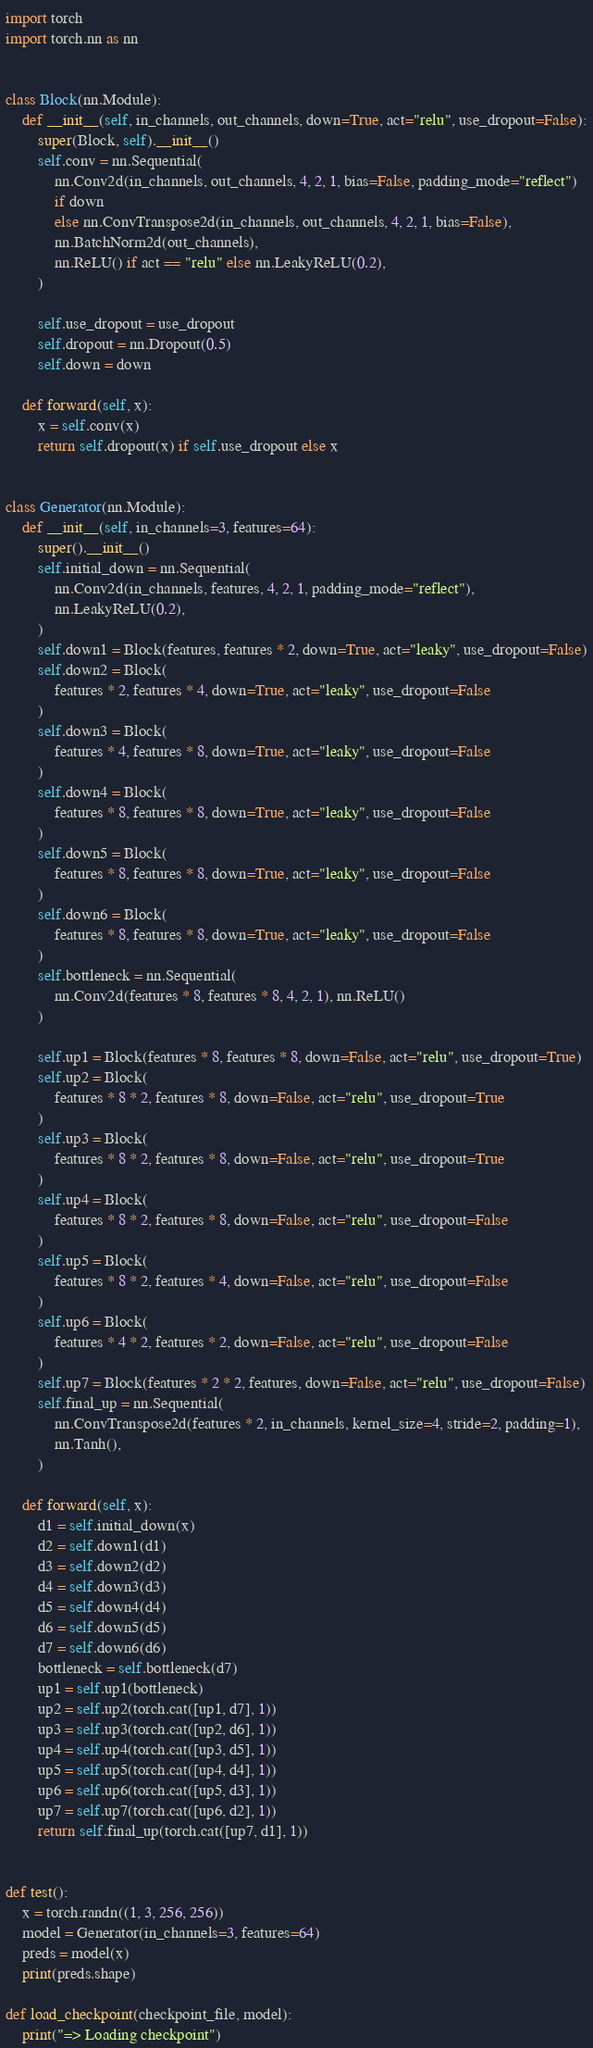Convert code to text. <code><loc_0><loc_0><loc_500><loc_500><_Python_>import torch
import torch.nn as nn


class Block(nn.Module):
    def __init__(self, in_channels, out_channels, down=True, act="relu", use_dropout=False):
        super(Block, self).__init__()
        self.conv = nn.Sequential(
            nn.Conv2d(in_channels, out_channels, 4, 2, 1, bias=False, padding_mode="reflect")
            if down
            else nn.ConvTranspose2d(in_channels, out_channels, 4, 2, 1, bias=False),
            nn.BatchNorm2d(out_channels),
            nn.ReLU() if act == "relu" else nn.LeakyReLU(0.2),
        )

        self.use_dropout = use_dropout
        self.dropout = nn.Dropout(0.5)
        self.down = down

    def forward(self, x):
        x = self.conv(x)
        return self.dropout(x) if self.use_dropout else x


class Generator(nn.Module):
    def __init__(self, in_channels=3, features=64):
        super().__init__()
        self.initial_down = nn.Sequential(
            nn.Conv2d(in_channels, features, 4, 2, 1, padding_mode="reflect"),
            nn.LeakyReLU(0.2),
        )
        self.down1 = Block(features, features * 2, down=True, act="leaky", use_dropout=False)
        self.down2 = Block(
            features * 2, features * 4, down=True, act="leaky", use_dropout=False
        )
        self.down3 = Block(
            features * 4, features * 8, down=True, act="leaky", use_dropout=False
        )
        self.down4 = Block(
            features * 8, features * 8, down=True, act="leaky", use_dropout=False
        )
        self.down5 = Block(
            features * 8, features * 8, down=True, act="leaky", use_dropout=False
        )
        self.down6 = Block(
            features * 8, features * 8, down=True, act="leaky", use_dropout=False
        )
        self.bottleneck = nn.Sequential(
            nn.Conv2d(features * 8, features * 8, 4, 2, 1), nn.ReLU()
        )

        self.up1 = Block(features * 8, features * 8, down=False, act="relu", use_dropout=True)
        self.up2 = Block(
            features * 8 * 2, features * 8, down=False, act="relu", use_dropout=True
        )
        self.up3 = Block(
            features * 8 * 2, features * 8, down=False, act="relu", use_dropout=True
        )
        self.up4 = Block(
            features * 8 * 2, features * 8, down=False, act="relu", use_dropout=False
        )
        self.up5 = Block(
            features * 8 * 2, features * 4, down=False, act="relu", use_dropout=False
        )
        self.up6 = Block(
            features * 4 * 2, features * 2, down=False, act="relu", use_dropout=False
        )
        self.up7 = Block(features * 2 * 2, features, down=False, act="relu", use_dropout=False)
        self.final_up = nn.Sequential(
            nn.ConvTranspose2d(features * 2, in_channels, kernel_size=4, stride=2, padding=1),
            nn.Tanh(),
        )

    def forward(self, x):
        d1 = self.initial_down(x)
        d2 = self.down1(d1)
        d3 = self.down2(d2)
        d4 = self.down3(d3)
        d5 = self.down4(d4)
        d6 = self.down5(d5)
        d7 = self.down6(d6)
        bottleneck = self.bottleneck(d7)
        up1 = self.up1(bottleneck)
        up2 = self.up2(torch.cat([up1, d7], 1))
        up3 = self.up3(torch.cat([up2, d6], 1))
        up4 = self.up4(torch.cat([up3, d5], 1))
        up5 = self.up5(torch.cat([up4, d4], 1))
        up6 = self.up6(torch.cat([up5, d3], 1))
        up7 = self.up7(torch.cat([up6, d2], 1))
        return self.final_up(torch.cat([up7, d1], 1))


def test():
    x = torch.randn((1, 3, 256, 256))
    model = Generator(in_channels=3, features=64)
    preds = model(x)
    print(preds.shape)

def load_checkpoint(checkpoint_file, model):
    print("=> Loading checkpoint")</code> 